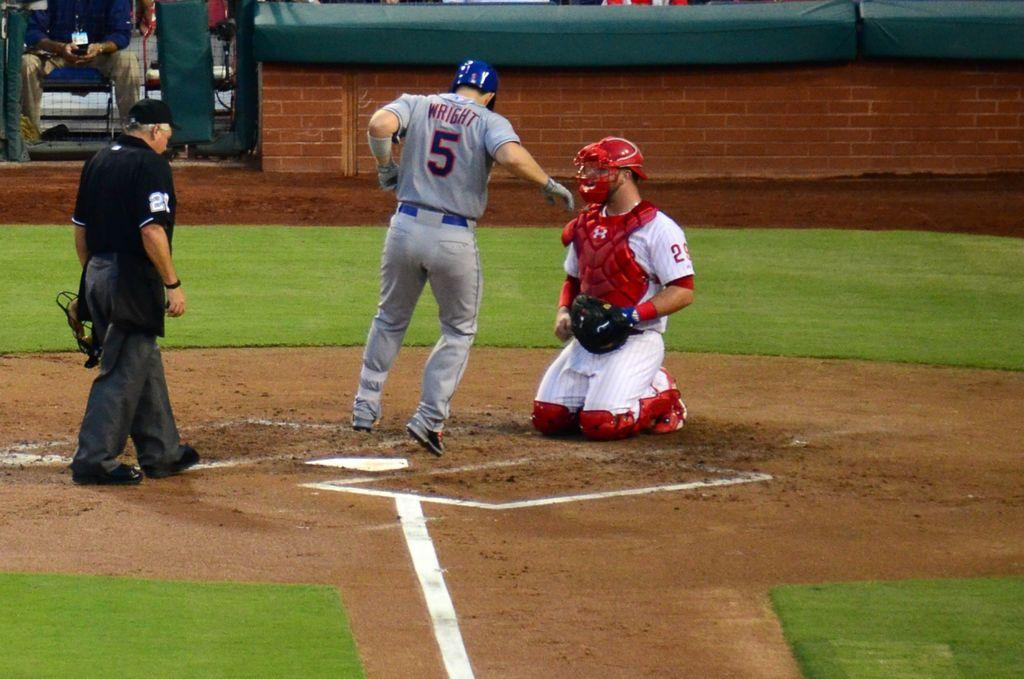<image>
Give a short and clear explanation of the subsequent image. a player with the number 5 crossing over home plate 